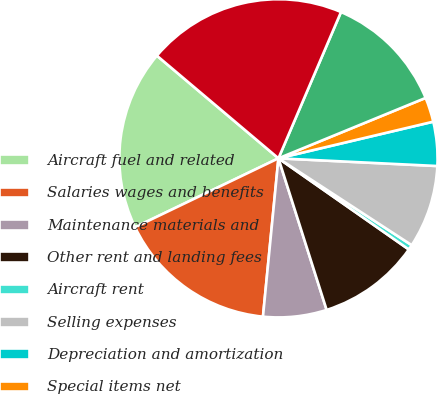<chart> <loc_0><loc_0><loc_500><loc_500><pie_chart><fcel>Aircraft fuel and related<fcel>Salaries wages and benefits<fcel>Maintenance materials and<fcel>Other rent and landing fees<fcel>Aircraft rent<fcel>Selling expenses<fcel>Depreciation and amortization<fcel>Special items net<fcel>Other<fcel>Total mainline operating<nl><fcel>18.29%<fcel>16.32%<fcel>6.45%<fcel>10.39%<fcel>0.52%<fcel>8.42%<fcel>4.47%<fcel>2.5%<fcel>12.37%<fcel>20.27%<nl></chart> 